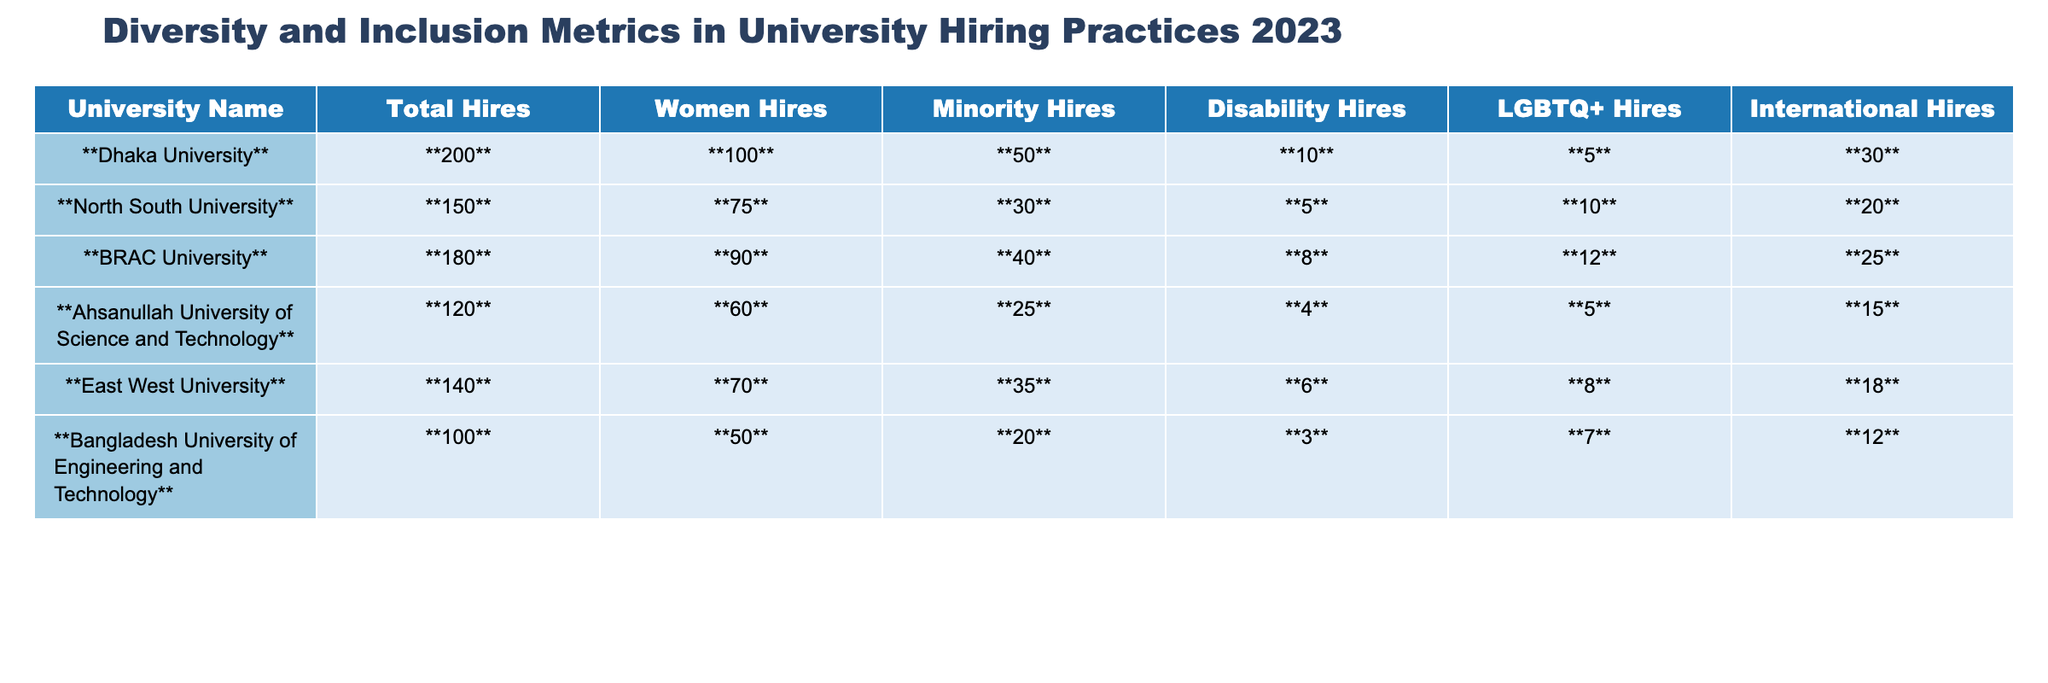What is the total number of hires at Dhaka University? The table shows the total hires for each university, and for Dhaka University, the total is indicated as 200.
Answer: 200 How many women were hired at BRAC University? The table lists the number of women hires at BRAC University, which is 90.
Answer: 90 What percentage of total hires at East West University are minority hires? To find the percentage, divide the number of minority hires (35) by the total hires (140) and multiply by 100. The calculation is (35/140) * 100 = 25%.
Answer: 25% Which university had the highest number of LGBTQ+ hires? By comparing the LGBTQ+ hires across universities, we find Dhaka University had the highest at 5.
Answer: Dhaka University Is the total number of disability hires at North South University greater than that at Ahsanullah University of Science and Technology? North South University had 5 disability hires, while Ahsanullah University had 4. Since 5 is greater than 4, the statement is true.
Answer: Yes What is the average number of international hires across all universities listed? Calculate the total international hires (30 + 20 + 25 + 15 + 18 + 12 = 120) and divide by the number of universities (6), which gives us 120/6 = 20.
Answer: 20 True or False: Bangladesh University of Engineering and Technology had more women hires than North South University. The table shows that Bangladesh University had 50 women hires, whereas North South University had 75. Thus, the statement is false.
Answer: False What is the difference between the total hires at Dhaka University and BRAC University? The total hires for Dhaka University is 200 and for BRAC University it's 180. The difference is 200 - 180 = 20.
Answer: 20 Considering only the minority hires, which university had the lowest number? The lowest number of minority hires is found by comparing the values across universities: Ahsanullah University had 25, which is the least among them.
Answer: Ahsanullah University Calculate the total number of hires for all universities combined. The summation of total hires from the table gives: 200 + 150 + 180 + 120 + 140 + 100 = 990.
Answer: 990 